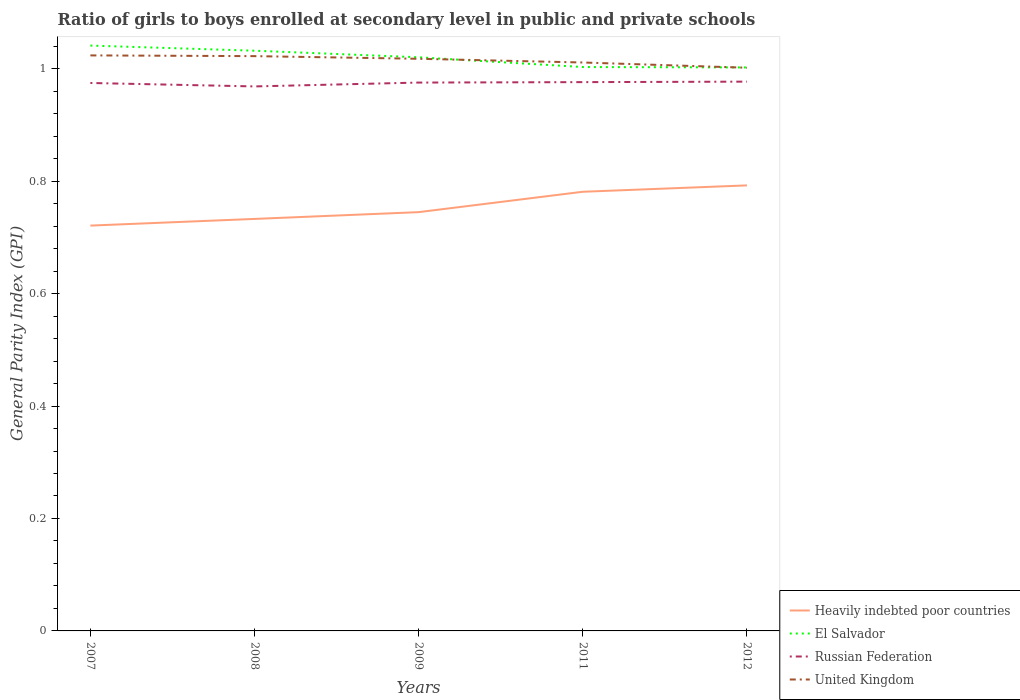How many different coloured lines are there?
Give a very brief answer. 4. Does the line corresponding to United Kingdom intersect with the line corresponding to El Salvador?
Ensure brevity in your answer.  Yes. Across all years, what is the maximum general parity index in United Kingdom?
Provide a succinct answer. 1. In which year was the general parity index in El Salvador maximum?
Ensure brevity in your answer.  2012. What is the total general parity index in El Salvador in the graph?
Give a very brief answer. 0.02. What is the difference between the highest and the second highest general parity index in Heavily indebted poor countries?
Make the answer very short. 0.07. How many years are there in the graph?
Ensure brevity in your answer.  5. Does the graph contain any zero values?
Give a very brief answer. No. How many legend labels are there?
Provide a succinct answer. 4. How are the legend labels stacked?
Provide a succinct answer. Vertical. What is the title of the graph?
Offer a very short reply. Ratio of girls to boys enrolled at secondary level in public and private schools. What is the label or title of the Y-axis?
Keep it short and to the point. General Parity Index (GPI). What is the General Parity Index (GPI) in Heavily indebted poor countries in 2007?
Give a very brief answer. 0.72. What is the General Parity Index (GPI) in El Salvador in 2007?
Your answer should be compact. 1.04. What is the General Parity Index (GPI) of Russian Federation in 2007?
Give a very brief answer. 0.97. What is the General Parity Index (GPI) in United Kingdom in 2007?
Make the answer very short. 1.02. What is the General Parity Index (GPI) in Heavily indebted poor countries in 2008?
Make the answer very short. 0.73. What is the General Parity Index (GPI) in El Salvador in 2008?
Your response must be concise. 1.03. What is the General Parity Index (GPI) of Russian Federation in 2008?
Provide a succinct answer. 0.97. What is the General Parity Index (GPI) in United Kingdom in 2008?
Keep it short and to the point. 1.02. What is the General Parity Index (GPI) of Heavily indebted poor countries in 2009?
Your answer should be very brief. 0.74. What is the General Parity Index (GPI) in El Salvador in 2009?
Offer a very short reply. 1.02. What is the General Parity Index (GPI) in Russian Federation in 2009?
Your answer should be compact. 0.98. What is the General Parity Index (GPI) in United Kingdom in 2009?
Your answer should be very brief. 1.02. What is the General Parity Index (GPI) in Heavily indebted poor countries in 2011?
Your answer should be compact. 0.78. What is the General Parity Index (GPI) in El Salvador in 2011?
Make the answer very short. 1. What is the General Parity Index (GPI) in Russian Federation in 2011?
Give a very brief answer. 0.98. What is the General Parity Index (GPI) of United Kingdom in 2011?
Provide a succinct answer. 1.01. What is the General Parity Index (GPI) in Heavily indebted poor countries in 2012?
Keep it short and to the point. 0.79. What is the General Parity Index (GPI) in El Salvador in 2012?
Give a very brief answer. 1. What is the General Parity Index (GPI) of Russian Federation in 2012?
Your answer should be compact. 0.98. What is the General Parity Index (GPI) of United Kingdom in 2012?
Provide a short and direct response. 1. Across all years, what is the maximum General Parity Index (GPI) of Heavily indebted poor countries?
Offer a terse response. 0.79. Across all years, what is the maximum General Parity Index (GPI) of El Salvador?
Offer a terse response. 1.04. Across all years, what is the maximum General Parity Index (GPI) of Russian Federation?
Provide a succinct answer. 0.98. Across all years, what is the maximum General Parity Index (GPI) in United Kingdom?
Ensure brevity in your answer.  1.02. Across all years, what is the minimum General Parity Index (GPI) of Heavily indebted poor countries?
Offer a very short reply. 0.72. Across all years, what is the minimum General Parity Index (GPI) of El Salvador?
Give a very brief answer. 1. Across all years, what is the minimum General Parity Index (GPI) of Russian Federation?
Keep it short and to the point. 0.97. Across all years, what is the minimum General Parity Index (GPI) of United Kingdom?
Make the answer very short. 1. What is the total General Parity Index (GPI) of Heavily indebted poor countries in the graph?
Make the answer very short. 3.77. What is the total General Parity Index (GPI) of El Salvador in the graph?
Offer a terse response. 5.1. What is the total General Parity Index (GPI) in Russian Federation in the graph?
Offer a very short reply. 4.87. What is the total General Parity Index (GPI) of United Kingdom in the graph?
Give a very brief answer. 5.08. What is the difference between the General Parity Index (GPI) in Heavily indebted poor countries in 2007 and that in 2008?
Provide a short and direct response. -0.01. What is the difference between the General Parity Index (GPI) of El Salvador in 2007 and that in 2008?
Provide a short and direct response. 0.01. What is the difference between the General Parity Index (GPI) of Russian Federation in 2007 and that in 2008?
Provide a short and direct response. 0.01. What is the difference between the General Parity Index (GPI) in United Kingdom in 2007 and that in 2008?
Your answer should be compact. 0. What is the difference between the General Parity Index (GPI) of Heavily indebted poor countries in 2007 and that in 2009?
Offer a very short reply. -0.02. What is the difference between the General Parity Index (GPI) in El Salvador in 2007 and that in 2009?
Give a very brief answer. 0.02. What is the difference between the General Parity Index (GPI) of Russian Federation in 2007 and that in 2009?
Offer a terse response. -0. What is the difference between the General Parity Index (GPI) of United Kingdom in 2007 and that in 2009?
Offer a very short reply. 0.01. What is the difference between the General Parity Index (GPI) in Heavily indebted poor countries in 2007 and that in 2011?
Provide a succinct answer. -0.06. What is the difference between the General Parity Index (GPI) of El Salvador in 2007 and that in 2011?
Your answer should be compact. 0.04. What is the difference between the General Parity Index (GPI) in Russian Federation in 2007 and that in 2011?
Your answer should be compact. -0. What is the difference between the General Parity Index (GPI) in United Kingdom in 2007 and that in 2011?
Offer a very short reply. 0.01. What is the difference between the General Parity Index (GPI) in Heavily indebted poor countries in 2007 and that in 2012?
Your answer should be compact. -0.07. What is the difference between the General Parity Index (GPI) of El Salvador in 2007 and that in 2012?
Ensure brevity in your answer.  0.04. What is the difference between the General Parity Index (GPI) of Russian Federation in 2007 and that in 2012?
Keep it short and to the point. -0. What is the difference between the General Parity Index (GPI) in United Kingdom in 2007 and that in 2012?
Make the answer very short. 0.02. What is the difference between the General Parity Index (GPI) of Heavily indebted poor countries in 2008 and that in 2009?
Your answer should be very brief. -0.01. What is the difference between the General Parity Index (GPI) of El Salvador in 2008 and that in 2009?
Provide a succinct answer. 0.01. What is the difference between the General Parity Index (GPI) in Russian Federation in 2008 and that in 2009?
Provide a short and direct response. -0.01. What is the difference between the General Parity Index (GPI) of United Kingdom in 2008 and that in 2009?
Your answer should be very brief. 0. What is the difference between the General Parity Index (GPI) in Heavily indebted poor countries in 2008 and that in 2011?
Provide a short and direct response. -0.05. What is the difference between the General Parity Index (GPI) of El Salvador in 2008 and that in 2011?
Offer a terse response. 0.03. What is the difference between the General Parity Index (GPI) in Russian Federation in 2008 and that in 2011?
Your answer should be compact. -0.01. What is the difference between the General Parity Index (GPI) of United Kingdom in 2008 and that in 2011?
Make the answer very short. 0.01. What is the difference between the General Parity Index (GPI) of Heavily indebted poor countries in 2008 and that in 2012?
Make the answer very short. -0.06. What is the difference between the General Parity Index (GPI) in El Salvador in 2008 and that in 2012?
Your answer should be very brief. 0.03. What is the difference between the General Parity Index (GPI) in Russian Federation in 2008 and that in 2012?
Offer a terse response. -0.01. What is the difference between the General Parity Index (GPI) of United Kingdom in 2008 and that in 2012?
Give a very brief answer. 0.02. What is the difference between the General Parity Index (GPI) of Heavily indebted poor countries in 2009 and that in 2011?
Your answer should be compact. -0.04. What is the difference between the General Parity Index (GPI) of El Salvador in 2009 and that in 2011?
Your response must be concise. 0.02. What is the difference between the General Parity Index (GPI) in Russian Federation in 2009 and that in 2011?
Offer a very short reply. -0. What is the difference between the General Parity Index (GPI) of United Kingdom in 2009 and that in 2011?
Your answer should be compact. 0.01. What is the difference between the General Parity Index (GPI) of Heavily indebted poor countries in 2009 and that in 2012?
Your answer should be very brief. -0.05. What is the difference between the General Parity Index (GPI) of El Salvador in 2009 and that in 2012?
Provide a short and direct response. 0.02. What is the difference between the General Parity Index (GPI) in Russian Federation in 2009 and that in 2012?
Make the answer very short. -0. What is the difference between the General Parity Index (GPI) in United Kingdom in 2009 and that in 2012?
Keep it short and to the point. 0.02. What is the difference between the General Parity Index (GPI) in Heavily indebted poor countries in 2011 and that in 2012?
Give a very brief answer. -0.01. What is the difference between the General Parity Index (GPI) of El Salvador in 2011 and that in 2012?
Your answer should be compact. 0. What is the difference between the General Parity Index (GPI) in Russian Federation in 2011 and that in 2012?
Your response must be concise. -0. What is the difference between the General Parity Index (GPI) in United Kingdom in 2011 and that in 2012?
Your response must be concise. 0.01. What is the difference between the General Parity Index (GPI) of Heavily indebted poor countries in 2007 and the General Parity Index (GPI) of El Salvador in 2008?
Provide a short and direct response. -0.31. What is the difference between the General Parity Index (GPI) in Heavily indebted poor countries in 2007 and the General Parity Index (GPI) in Russian Federation in 2008?
Provide a succinct answer. -0.25. What is the difference between the General Parity Index (GPI) in Heavily indebted poor countries in 2007 and the General Parity Index (GPI) in United Kingdom in 2008?
Your answer should be compact. -0.3. What is the difference between the General Parity Index (GPI) in El Salvador in 2007 and the General Parity Index (GPI) in Russian Federation in 2008?
Your answer should be very brief. 0.07. What is the difference between the General Parity Index (GPI) in El Salvador in 2007 and the General Parity Index (GPI) in United Kingdom in 2008?
Provide a short and direct response. 0.02. What is the difference between the General Parity Index (GPI) of Russian Federation in 2007 and the General Parity Index (GPI) of United Kingdom in 2008?
Provide a succinct answer. -0.05. What is the difference between the General Parity Index (GPI) of Heavily indebted poor countries in 2007 and the General Parity Index (GPI) of El Salvador in 2009?
Provide a succinct answer. -0.3. What is the difference between the General Parity Index (GPI) of Heavily indebted poor countries in 2007 and the General Parity Index (GPI) of Russian Federation in 2009?
Make the answer very short. -0.25. What is the difference between the General Parity Index (GPI) of Heavily indebted poor countries in 2007 and the General Parity Index (GPI) of United Kingdom in 2009?
Your response must be concise. -0.3. What is the difference between the General Parity Index (GPI) of El Salvador in 2007 and the General Parity Index (GPI) of Russian Federation in 2009?
Your answer should be very brief. 0.07. What is the difference between the General Parity Index (GPI) in El Salvador in 2007 and the General Parity Index (GPI) in United Kingdom in 2009?
Give a very brief answer. 0.02. What is the difference between the General Parity Index (GPI) of Russian Federation in 2007 and the General Parity Index (GPI) of United Kingdom in 2009?
Ensure brevity in your answer.  -0.04. What is the difference between the General Parity Index (GPI) in Heavily indebted poor countries in 2007 and the General Parity Index (GPI) in El Salvador in 2011?
Your response must be concise. -0.28. What is the difference between the General Parity Index (GPI) in Heavily indebted poor countries in 2007 and the General Parity Index (GPI) in Russian Federation in 2011?
Your answer should be very brief. -0.26. What is the difference between the General Parity Index (GPI) in Heavily indebted poor countries in 2007 and the General Parity Index (GPI) in United Kingdom in 2011?
Give a very brief answer. -0.29. What is the difference between the General Parity Index (GPI) of El Salvador in 2007 and the General Parity Index (GPI) of Russian Federation in 2011?
Ensure brevity in your answer.  0.07. What is the difference between the General Parity Index (GPI) in El Salvador in 2007 and the General Parity Index (GPI) in United Kingdom in 2011?
Keep it short and to the point. 0.03. What is the difference between the General Parity Index (GPI) in Russian Federation in 2007 and the General Parity Index (GPI) in United Kingdom in 2011?
Your response must be concise. -0.04. What is the difference between the General Parity Index (GPI) in Heavily indebted poor countries in 2007 and the General Parity Index (GPI) in El Salvador in 2012?
Your answer should be very brief. -0.28. What is the difference between the General Parity Index (GPI) of Heavily indebted poor countries in 2007 and the General Parity Index (GPI) of Russian Federation in 2012?
Your response must be concise. -0.26. What is the difference between the General Parity Index (GPI) of Heavily indebted poor countries in 2007 and the General Parity Index (GPI) of United Kingdom in 2012?
Offer a very short reply. -0.28. What is the difference between the General Parity Index (GPI) of El Salvador in 2007 and the General Parity Index (GPI) of Russian Federation in 2012?
Keep it short and to the point. 0.06. What is the difference between the General Parity Index (GPI) of El Salvador in 2007 and the General Parity Index (GPI) of United Kingdom in 2012?
Provide a short and direct response. 0.04. What is the difference between the General Parity Index (GPI) of Russian Federation in 2007 and the General Parity Index (GPI) of United Kingdom in 2012?
Your answer should be compact. -0.03. What is the difference between the General Parity Index (GPI) of Heavily indebted poor countries in 2008 and the General Parity Index (GPI) of El Salvador in 2009?
Give a very brief answer. -0.29. What is the difference between the General Parity Index (GPI) of Heavily indebted poor countries in 2008 and the General Parity Index (GPI) of Russian Federation in 2009?
Provide a succinct answer. -0.24. What is the difference between the General Parity Index (GPI) in Heavily indebted poor countries in 2008 and the General Parity Index (GPI) in United Kingdom in 2009?
Provide a succinct answer. -0.28. What is the difference between the General Parity Index (GPI) in El Salvador in 2008 and the General Parity Index (GPI) in Russian Federation in 2009?
Give a very brief answer. 0.06. What is the difference between the General Parity Index (GPI) of El Salvador in 2008 and the General Parity Index (GPI) of United Kingdom in 2009?
Provide a short and direct response. 0.01. What is the difference between the General Parity Index (GPI) of Russian Federation in 2008 and the General Parity Index (GPI) of United Kingdom in 2009?
Ensure brevity in your answer.  -0.05. What is the difference between the General Parity Index (GPI) of Heavily indebted poor countries in 2008 and the General Parity Index (GPI) of El Salvador in 2011?
Give a very brief answer. -0.27. What is the difference between the General Parity Index (GPI) of Heavily indebted poor countries in 2008 and the General Parity Index (GPI) of Russian Federation in 2011?
Offer a terse response. -0.24. What is the difference between the General Parity Index (GPI) in Heavily indebted poor countries in 2008 and the General Parity Index (GPI) in United Kingdom in 2011?
Offer a very short reply. -0.28. What is the difference between the General Parity Index (GPI) in El Salvador in 2008 and the General Parity Index (GPI) in Russian Federation in 2011?
Offer a very short reply. 0.06. What is the difference between the General Parity Index (GPI) of El Salvador in 2008 and the General Parity Index (GPI) of United Kingdom in 2011?
Your answer should be compact. 0.02. What is the difference between the General Parity Index (GPI) in Russian Federation in 2008 and the General Parity Index (GPI) in United Kingdom in 2011?
Provide a short and direct response. -0.04. What is the difference between the General Parity Index (GPI) in Heavily indebted poor countries in 2008 and the General Parity Index (GPI) in El Salvador in 2012?
Your answer should be compact. -0.27. What is the difference between the General Parity Index (GPI) in Heavily indebted poor countries in 2008 and the General Parity Index (GPI) in Russian Federation in 2012?
Make the answer very short. -0.24. What is the difference between the General Parity Index (GPI) of Heavily indebted poor countries in 2008 and the General Parity Index (GPI) of United Kingdom in 2012?
Your answer should be compact. -0.27. What is the difference between the General Parity Index (GPI) in El Salvador in 2008 and the General Parity Index (GPI) in Russian Federation in 2012?
Your answer should be compact. 0.06. What is the difference between the General Parity Index (GPI) of El Salvador in 2008 and the General Parity Index (GPI) of United Kingdom in 2012?
Provide a short and direct response. 0.03. What is the difference between the General Parity Index (GPI) in Russian Federation in 2008 and the General Parity Index (GPI) in United Kingdom in 2012?
Your response must be concise. -0.03. What is the difference between the General Parity Index (GPI) in Heavily indebted poor countries in 2009 and the General Parity Index (GPI) in El Salvador in 2011?
Give a very brief answer. -0.26. What is the difference between the General Parity Index (GPI) in Heavily indebted poor countries in 2009 and the General Parity Index (GPI) in Russian Federation in 2011?
Ensure brevity in your answer.  -0.23. What is the difference between the General Parity Index (GPI) of Heavily indebted poor countries in 2009 and the General Parity Index (GPI) of United Kingdom in 2011?
Make the answer very short. -0.27. What is the difference between the General Parity Index (GPI) of El Salvador in 2009 and the General Parity Index (GPI) of Russian Federation in 2011?
Provide a short and direct response. 0.04. What is the difference between the General Parity Index (GPI) in El Salvador in 2009 and the General Parity Index (GPI) in United Kingdom in 2011?
Provide a short and direct response. 0.01. What is the difference between the General Parity Index (GPI) in Russian Federation in 2009 and the General Parity Index (GPI) in United Kingdom in 2011?
Provide a short and direct response. -0.04. What is the difference between the General Parity Index (GPI) in Heavily indebted poor countries in 2009 and the General Parity Index (GPI) in El Salvador in 2012?
Ensure brevity in your answer.  -0.26. What is the difference between the General Parity Index (GPI) in Heavily indebted poor countries in 2009 and the General Parity Index (GPI) in Russian Federation in 2012?
Ensure brevity in your answer.  -0.23. What is the difference between the General Parity Index (GPI) in Heavily indebted poor countries in 2009 and the General Parity Index (GPI) in United Kingdom in 2012?
Keep it short and to the point. -0.26. What is the difference between the General Parity Index (GPI) in El Salvador in 2009 and the General Parity Index (GPI) in Russian Federation in 2012?
Offer a terse response. 0.04. What is the difference between the General Parity Index (GPI) of El Salvador in 2009 and the General Parity Index (GPI) of United Kingdom in 2012?
Offer a terse response. 0.02. What is the difference between the General Parity Index (GPI) in Russian Federation in 2009 and the General Parity Index (GPI) in United Kingdom in 2012?
Ensure brevity in your answer.  -0.03. What is the difference between the General Parity Index (GPI) in Heavily indebted poor countries in 2011 and the General Parity Index (GPI) in El Salvador in 2012?
Your answer should be compact. -0.22. What is the difference between the General Parity Index (GPI) in Heavily indebted poor countries in 2011 and the General Parity Index (GPI) in Russian Federation in 2012?
Your answer should be compact. -0.2. What is the difference between the General Parity Index (GPI) in Heavily indebted poor countries in 2011 and the General Parity Index (GPI) in United Kingdom in 2012?
Offer a terse response. -0.22. What is the difference between the General Parity Index (GPI) in El Salvador in 2011 and the General Parity Index (GPI) in Russian Federation in 2012?
Keep it short and to the point. 0.03. What is the difference between the General Parity Index (GPI) in El Salvador in 2011 and the General Parity Index (GPI) in United Kingdom in 2012?
Ensure brevity in your answer.  0. What is the difference between the General Parity Index (GPI) of Russian Federation in 2011 and the General Parity Index (GPI) of United Kingdom in 2012?
Keep it short and to the point. -0.03. What is the average General Parity Index (GPI) of Heavily indebted poor countries per year?
Your answer should be very brief. 0.75. What is the average General Parity Index (GPI) in El Salvador per year?
Your response must be concise. 1.02. What is the average General Parity Index (GPI) in Russian Federation per year?
Provide a short and direct response. 0.97. What is the average General Parity Index (GPI) in United Kingdom per year?
Your answer should be compact. 1.02. In the year 2007, what is the difference between the General Parity Index (GPI) in Heavily indebted poor countries and General Parity Index (GPI) in El Salvador?
Ensure brevity in your answer.  -0.32. In the year 2007, what is the difference between the General Parity Index (GPI) in Heavily indebted poor countries and General Parity Index (GPI) in Russian Federation?
Your answer should be compact. -0.25. In the year 2007, what is the difference between the General Parity Index (GPI) of Heavily indebted poor countries and General Parity Index (GPI) of United Kingdom?
Make the answer very short. -0.3. In the year 2007, what is the difference between the General Parity Index (GPI) in El Salvador and General Parity Index (GPI) in Russian Federation?
Offer a terse response. 0.07. In the year 2007, what is the difference between the General Parity Index (GPI) of El Salvador and General Parity Index (GPI) of United Kingdom?
Offer a very short reply. 0.02. In the year 2007, what is the difference between the General Parity Index (GPI) of Russian Federation and General Parity Index (GPI) of United Kingdom?
Offer a very short reply. -0.05. In the year 2008, what is the difference between the General Parity Index (GPI) in Heavily indebted poor countries and General Parity Index (GPI) in El Salvador?
Your answer should be compact. -0.3. In the year 2008, what is the difference between the General Parity Index (GPI) of Heavily indebted poor countries and General Parity Index (GPI) of Russian Federation?
Your answer should be compact. -0.24. In the year 2008, what is the difference between the General Parity Index (GPI) in Heavily indebted poor countries and General Parity Index (GPI) in United Kingdom?
Ensure brevity in your answer.  -0.29. In the year 2008, what is the difference between the General Parity Index (GPI) of El Salvador and General Parity Index (GPI) of Russian Federation?
Your response must be concise. 0.06. In the year 2008, what is the difference between the General Parity Index (GPI) of El Salvador and General Parity Index (GPI) of United Kingdom?
Offer a terse response. 0.01. In the year 2008, what is the difference between the General Parity Index (GPI) of Russian Federation and General Parity Index (GPI) of United Kingdom?
Offer a very short reply. -0.05. In the year 2009, what is the difference between the General Parity Index (GPI) of Heavily indebted poor countries and General Parity Index (GPI) of El Salvador?
Give a very brief answer. -0.28. In the year 2009, what is the difference between the General Parity Index (GPI) in Heavily indebted poor countries and General Parity Index (GPI) in Russian Federation?
Offer a terse response. -0.23. In the year 2009, what is the difference between the General Parity Index (GPI) of Heavily indebted poor countries and General Parity Index (GPI) of United Kingdom?
Offer a very short reply. -0.27. In the year 2009, what is the difference between the General Parity Index (GPI) in El Salvador and General Parity Index (GPI) in Russian Federation?
Ensure brevity in your answer.  0.04. In the year 2009, what is the difference between the General Parity Index (GPI) in El Salvador and General Parity Index (GPI) in United Kingdom?
Your response must be concise. 0. In the year 2009, what is the difference between the General Parity Index (GPI) of Russian Federation and General Parity Index (GPI) of United Kingdom?
Ensure brevity in your answer.  -0.04. In the year 2011, what is the difference between the General Parity Index (GPI) in Heavily indebted poor countries and General Parity Index (GPI) in El Salvador?
Your answer should be compact. -0.22. In the year 2011, what is the difference between the General Parity Index (GPI) of Heavily indebted poor countries and General Parity Index (GPI) of Russian Federation?
Keep it short and to the point. -0.2. In the year 2011, what is the difference between the General Parity Index (GPI) in Heavily indebted poor countries and General Parity Index (GPI) in United Kingdom?
Give a very brief answer. -0.23. In the year 2011, what is the difference between the General Parity Index (GPI) in El Salvador and General Parity Index (GPI) in Russian Federation?
Keep it short and to the point. 0.03. In the year 2011, what is the difference between the General Parity Index (GPI) in El Salvador and General Parity Index (GPI) in United Kingdom?
Provide a short and direct response. -0.01. In the year 2011, what is the difference between the General Parity Index (GPI) of Russian Federation and General Parity Index (GPI) of United Kingdom?
Offer a very short reply. -0.03. In the year 2012, what is the difference between the General Parity Index (GPI) in Heavily indebted poor countries and General Parity Index (GPI) in El Salvador?
Provide a succinct answer. -0.21. In the year 2012, what is the difference between the General Parity Index (GPI) of Heavily indebted poor countries and General Parity Index (GPI) of Russian Federation?
Provide a succinct answer. -0.18. In the year 2012, what is the difference between the General Parity Index (GPI) in Heavily indebted poor countries and General Parity Index (GPI) in United Kingdom?
Your response must be concise. -0.21. In the year 2012, what is the difference between the General Parity Index (GPI) of El Salvador and General Parity Index (GPI) of Russian Federation?
Your response must be concise. 0.03. In the year 2012, what is the difference between the General Parity Index (GPI) of El Salvador and General Parity Index (GPI) of United Kingdom?
Provide a short and direct response. 0. In the year 2012, what is the difference between the General Parity Index (GPI) of Russian Federation and General Parity Index (GPI) of United Kingdom?
Provide a short and direct response. -0.02. What is the ratio of the General Parity Index (GPI) of Heavily indebted poor countries in 2007 to that in 2008?
Provide a succinct answer. 0.98. What is the ratio of the General Parity Index (GPI) of El Salvador in 2007 to that in 2008?
Provide a succinct answer. 1.01. What is the ratio of the General Parity Index (GPI) in Russian Federation in 2007 to that in 2008?
Your answer should be very brief. 1.01. What is the ratio of the General Parity Index (GPI) in Heavily indebted poor countries in 2007 to that in 2009?
Your answer should be compact. 0.97. What is the ratio of the General Parity Index (GPI) of El Salvador in 2007 to that in 2009?
Your answer should be very brief. 1.02. What is the ratio of the General Parity Index (GPI) in Russian Federation in 2007 to that in 2009?
Give a very brief answer. 1. What is the ratio of the General Parity Index (GPI) of United Kingdom in 2007 to that in 2009?
Provide a short and direct response. 1.01. What is the ratio of the General Parity Index (GPI) in Heavily indebted poor countries in 2007 to that in 2011?
Offer a very short reply. 0.92. What is the ratio of the General Parity Index (GPI) in El Salvador in 2007 to that in 2011?
Offer a very short reply. 1.04. What is the ratio of the General Parity Index (GPI) in United Kingdom in 2007 to that in 2011?
Make the answer very short. 1.01. What is the ratio of the General Parity Index (GPI) of Heavily indebted poor countries in 2007 to that in 2012?
Your response must be concise. 0.91. What is the ratio of the General Parity Index (GPI) in El Salvador in 2007 to that in 2012?
Make the answer very short. 1.04. What is the ratio of the General Parity Index (GPI) of Russian Federation in 2007 to that in 2012?
Ensure brevity in your answer.  1. What is the ratio of the General Parity Index (GPI) in United Kingdom in 2007 to that in 2012?
Your answer should be compact. 1.02. What is the ratio of the General Parity Index (GPI) of Heavily indebted poor countries in 2008 to that in 2009?
Offer a very short reply. 0.98. What is the ratio of the General Parity Index (GPI) in El Salvador in 2008 to that in 2009?
Make the answer very short. 1.01. What is the ratio of the General Parity Index (GPI) of Heavily indebted poor countries in 2008 to that in 2011?
Keep it short and to the point. 0.94. What is the ratio of the General Parity Index (GPI) of Russian Federation in 2008 to that in 2011?
Make the answer very short. 0.99. What is the ratio of the General Parity Index (GPI) in United Kingdom in 2008 to that in 2011?
Your answer should be compact. 1.01. What is the ratio of the General Parity Index (GPI) of Heavily indebted poor countries in 2008 to that in 2012?
Ensure brevity in your answer.  0.92. What is the ratio of the General Parity Index (GPI) in El Salvador in 2008 to that in 2012?
Offer a terse response. 1.03. What is the ratio of the General Parity Index (GPI) in Russian Federation in 2008 to that in 2012?
Keep it short and to the point. 0.99. What is the ratio of the General Parity Index (GPI) of United Kingdom in 2008 to that in 2012?
Your answer should be very brief. 1.02. What is the ratio of the General Parity Index (GPI) of Heavily indebted poor countries in 2009 to that in 2011?
Provide a short and direct response. 0.95. What is the ratio of the General Parity Index (GPI) of El Salvador in 2009 to that in 2011?
Make the answer very short. 1.02. What is the ratio of the General Parity Index (GPI) of El Salvador in 2009 to that in 2012?
Offer a very short reply. 1.02. What is the ratio of the General Parity Index (GPI) of Russian Federation in 2009 to that in 2012?
Make the answer very short. 1. What is the ratio of the General Parity Index (GPI) of United Kingdom in 2009 to that in 2012?
Give a very brief answer. 1.02. What is the ratio of the General Parity Index (GPI) in Heavily indebted poor countries in 2011 to that in 2012?
Ensure brevity in your answer.  0.99. What is the ratio of the General Parity Index (GPI) of El Salvador in 2011 to that in 2012?
Your answer should be very brief. 1. What is the ratio of the General Parity Index (GPI) of Russian Federation in 2011 to that in 2012?
Offer a very short reply. 1. What is the ratio of the General Parity Index (GPI) in United Kingdom in 2011 to that in 2012?
Provide a succinct answer. 1.01. What is the difference between the highest and the second highest General Parity Index (GPI) of Heavily indebted poor countries?
Keep it short and to the point. 0.01. What is the difference between the highest and the second highest General Parity Index (GPI) of El Salvador?
Ensure brevity in your answer.  0.01. What is the difference between the highest and the second highest General Parity Index (GPI) in Russian Federation?
Your answer should be compact. 0. What is the difference between the highest and the second highest General Parity Index (GPI) in United Kingdom?
Your response must be concise. 0. What is the difference between the highest and the lowest General Parity Index (GPI) in Heavily indebted poor countries?
Offer a terse response. 0.07. What is the difference between the highest and the lowest General Parity Index (GPI) of El Salvador?
Make the answer very short. 0.04. What is the difference between the highest and the lowest General Parity Index (GPI) in Russian Federation?
Offer a terse response. 0.01. What is the difference between the highest and the lowest General Parity Index (GPI) in United Kingdom?
Offer a terse response. 0.02. 